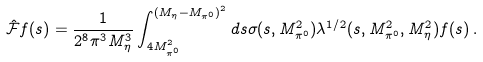<formula> <loc_0><loc_0><loc_500><loc_500>\hat { \mathcal { F } } f ( s ) = \frac { 1 } { 2 ^ { 8 } \pi ^ { 3 } M _ { \eta } ^ { 3 } } \int _ { 4 M _ { \pi ^ { 0 } } ^ { 2 } } ^ { ( M _ { \eta } - M _ { \pi ^ { 0 } } ) ^ { 2 } } d s \sigma ( s , M _ { \pi ^ { 0 } } ^ { 2 } ) \lambda ^ { 1 / 2 } ( s , M _ { \pi ^ { 0 } } ^ { 2 } , M _ { \eta } ^ { 2 } ) f ( s ) \, .</formula> 